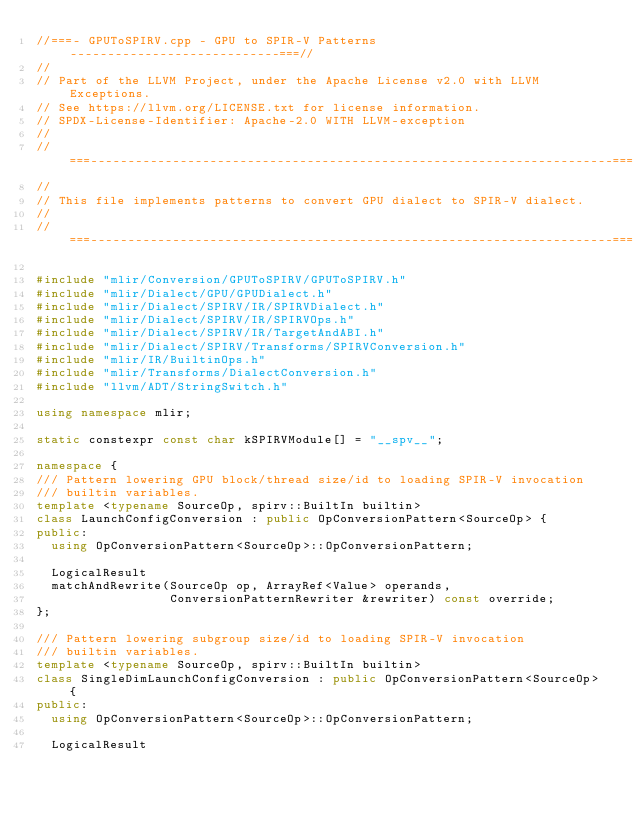<code> <loc_0><loc_0><loc_500><loc_500><_C++_>//===- GPUToSPIRV.cpp - GPU to SPIR-V Patterns ----------------------------===//
//
// Part of the LLVM Project, under the Apache License v2.0 with LLVM Exceptions.
// See https://llvm.org/LICENSE.txt for license information.
// SPDX-License-Identifier: Apache-2.0 WITH LLVM-exception
//
//===----------------------------------------------------------------------===//
//
// This file implements patterns to convert GPU dialect to SPIR-V dialect.
//
//===----------------------------------------------------------------------===//

#include "mlir/Conversion/GPUToSPIRV/GPUToSPIRV.h"
#include "mlir/Dialect/GPU/GPUDialect.h"
#include "mlir/Dialect/SPIRV/IR/SPIRVDialect.h"
#include "mlir/Dialect/SPIRV/IR/SPIRVOps.h"
#include "mlir/Dialect/SPIRV/IR/TargetAndABI.h"
#include "mlir/Dialect/SPIRV/Transforms/SPIRVConversion.h"
#include "mlir/IR/BuiltinOps.h"
#include "mlir/Transforms/DialectConversion.h"
#include "llvm/ADT/StringSwitch.h"

using namespace mlir;

static constexpr const char kSPIRVModule[] = "__spv__";

namespace {
/// Pattern lowering GPU block/thread size/id to loading SPIR-V invocation
/// builtin variables.
template <typename SourceOp, spirv::BuiltIn builtin>
class LaunchConfigConversion : public OpConversionPattern<SourceOp> {
public:
  using OpConversionPattern<SourceOp>::OpConversionPattern;

  LogicalResult
  matchAndRewrite(SourceOp op, ArrayRef<Value> operands,
                  ConversionPatternRewriter &rewriter) const override;
};

/// Pattern lowering subgroup size/id to loading SPIR-V invocation
/// builtin variables.
template <typename SourceOp, spirv::BuiltIn builtin>
class SingleDimLaunchConfigConversion : public OpConversionPattern<SourceOp> {
public:
  using OpConversionPattern<SourceOp>::OpConversionPattern;

  LogicalResult</code> 